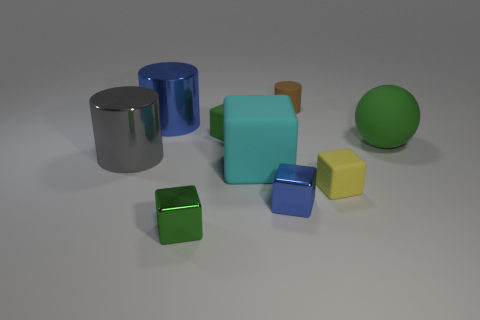Subtract all cyan cubes. How many cubes are left? 4 Subtract all large cyan rubber cubes. How many cubes are left? 4 Subtract 2 cubes. How many cubes are left? 3 Subtract all brown blocks. Subtract all purple spheres. How many blocks are left? 5 Subtract all blocks. How many objects are left? 4 Subtract 0 brown spheres. How many objects are left? 9 Subtract all big blocks. Subtract all brown things. How many objects are left? 7 Add 7 tiny brown rubber objects. How many tiny brown rubber objects are left? 8 Add 5 big blocks. How many big blocks exist? 6 